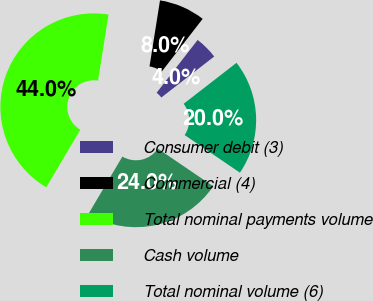Convert chart. <chart><loc_0><loc_0><loc_500><loc_500><pie_chart><fcel>Consumer debit (3)<fcel>Commercial (4)<fcel>Total nominal payments volume<fcel>Cash volume<fcel>Total nominal volume (6)<nl><fcel>4.0%<fcel>8.0%<fcel>44.0%<fcel>24.0%<fcel>20.0%<nl></chart> 